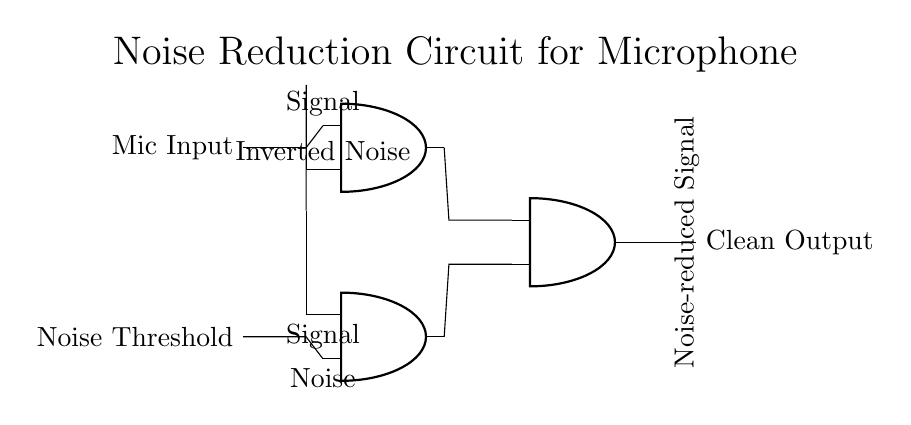What does the mic input represent in this circuit? The mic input represents the raw audio signal captured by the microphone before any processing is applied, indicating the starting point of the signal flow through the circuit.
Answer: Mic Input How many AND gates are present in this circuit? There are three AND gates in the circuit, which are indicated by the three AND gate symbols shown in the diagram, revealing how the circuit processes the signals.
Answer: Three What inputs does the top AND gate receive? The top AND gate receives a signal input and an inverted noise input. This is determined by tracing the connections into the gate, confirming the sources and their types.
Answer: Signal, Inverted Noise What is the output of the last AND gate called? The output of the last AND gate is called the noise-reduced signal. This is labeled at the end of the circuit diagram, showing that it represents the final clean output after noise has been filtered out.
Answer: Noise-reduced Signal What role does the noise threshold play in this circuit? The noise threshold helps to determine whether the input signal should be considered as noise or a usable signal, influencing the logic decision inside the AND gates to clean the input.
Answer: Noise Threshold How many types of inputs are there connected to the bottom AND gate? There are two types of inputs connected to the bottom AND gate: a signal input and a noise input, which affect how the AND gate processes these signals to produce the output.
Answer: Two Which component processes the inverted noise input? The component that processes the inverted noise input is the top AND gate, which blends this inverted signal with the microphone signal to help in reducing noise interference.
Answer: Top AND gate 